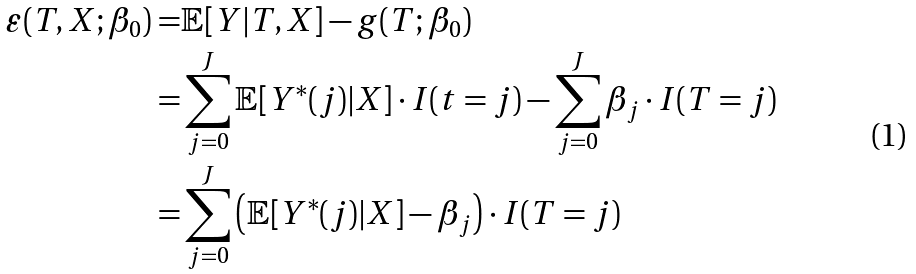<formula> <loc_0><loc_0><loc_500><loc_500>\varepsilon ( T , X ; \beta _ { 0 } ) = & \mathbb { E } [ Y | T , X ] - g ( T ; \beta _ { 0 } ) \\ = & \sum _ { j = 0 } ^ { J } \mathbb { E } [ Y ^ { * } ( j ) | X ] \cdot I ( t = j ) - \sum _ { j = 0 } ^ { J } \beta _ { j } \cdot I ( T = j ) \\ = & \sum _ { j = 0 } ^ { J } \left ( \mathbb { E } [ Y ^ { * } ( j ) | X ] - \beta _ { j } \right ) \cdot I ( T = j )</formula> 